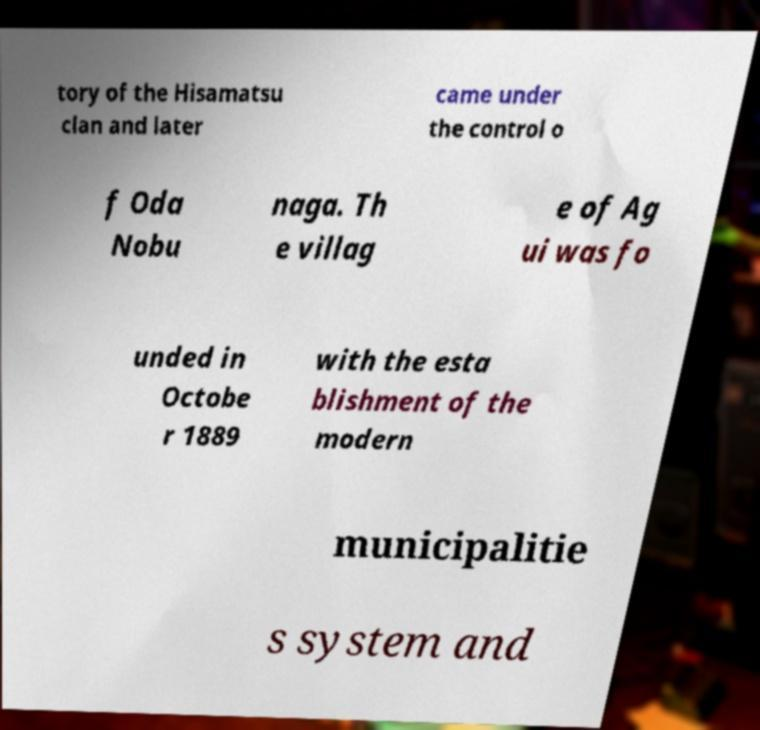For documentation purposes, I need the text within this image transcribed. Could you provide that? tory of the Hisamatsu clan and later came under the control o f Oda Nobu naga. Th e villag e of Ag ui was fo unded in Octobe r 1889 with the esta blishment of the modern municipalitie s system and 